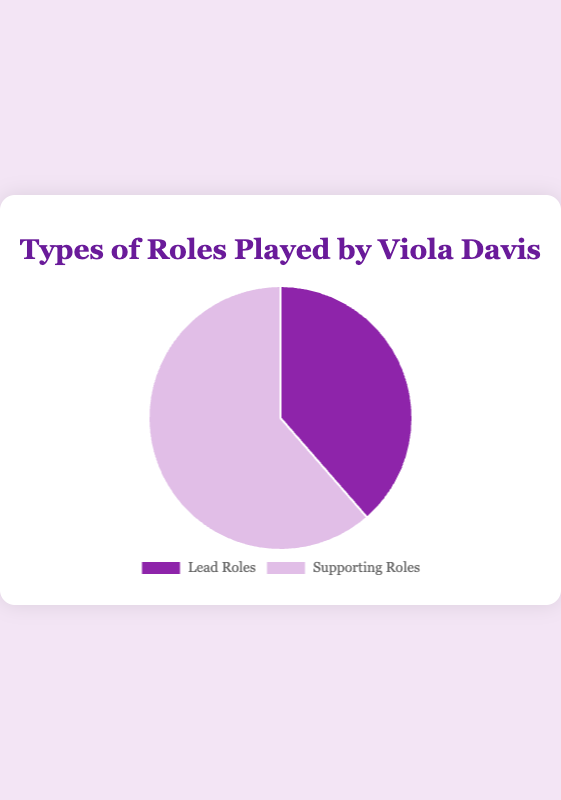What's the ratio of Supporting Roles to Lead Roles? To find the ratio, divide the number of Supporting Roles by the number of Lead Roles. Therefore, the ratio is 35/22, which simplifies to approximately 1.59 when rounded to two decimal places.
Answer: 1.59 Which type of role does Viola Davis play more frequently? By comparing the counts, Viola Davis has played 35 Supporting Roles and 22 Lead Roles. Since 35 is greater than 22, she plays Supporting Roles more frequently.
Answer: Supporting Roles What percentage of all her roles are Lead Roles? First, find the total number of roles by adding Lead and Supporting Roles (22 + 35 = 57). Then, divide the number of Lead Roles by the total and multiply by 100 to get the percentage (22 / 57 * 100 ≈ 38.60%).
Answer: 38.60% By how much do the Supporting Roles exceed Lead Roles? Subtract the number of Lead Roles from the number of Supporting Roles. So, 35 - 22 = 13. Thus, Supporting Roles exceed Lead Roles by 13.
Answer: 13 What is the combined total of Lead and Supporting Roles? To find the total, just add the number of Lead Roles and Supporting Roles together. So, 22 + 35 = 57.
Answer: 57 If Viola Davis were to take 3 more Lead Roles, what would be the new ratio of Lead to Supporting Roles? If she takes 3 more Lead Roles, the new count becomes 22 + 3 = 25. The number of Supporting Roles remains 35. The new ratio is 25/35, which simplifies to 5/7 or approximately 0.71.
Answer: 0.71 Which color is associated with Supporting Roles in the pie chart? The color for Supporting Roles in the pie chart is visually presented as light purple.
Answer: light purple What fraction of her roles are Supporting Roles? The fraction is obtained by placing the number of Supporting Roles over the total number of roles. So, Supporting Roles make up 35/57 of her roles. Simplify if necessary.
Answer: 35/57 How much do Supporting Roles and Lead Roles each contribute to the total, in terms of percentages? Supporting Roles: 35/57 ≈ 61.40%, Lead Roles: 22/57 ≈ 38.60%. Simply divide each type by the total and multiply by 100.
Answer: Supporting: 61.40%, Lead: 38.60% If another chart is shown with 50 Lead Roles and the same number of Supporting Roles (35), by what factor would the Lead Roles increase? The initial count of Lead Roles is 22. If it increases to 50, the factor of increase is 50 / 22 ≈ 2.27.
Answer: 2.27 